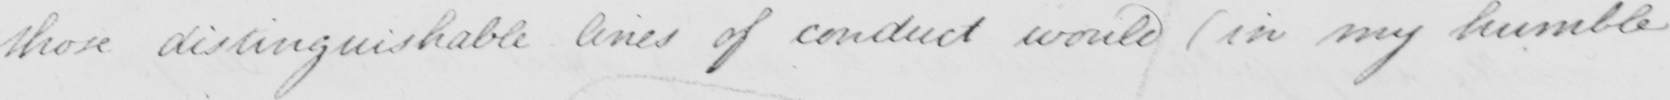What does this handwritten line say? those distinguishable lines of conduct would (in my humble 